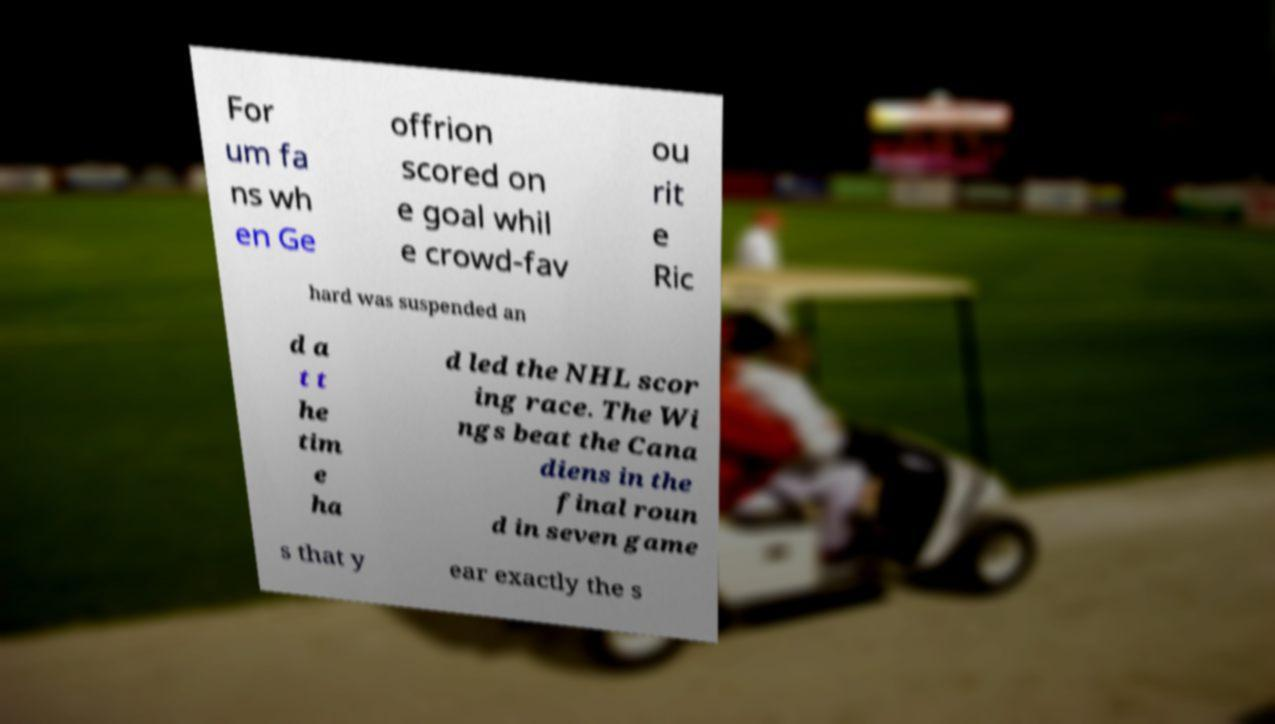I need the written content from this picture converted into text. Can you do that? For um fa ns wh en Ge offrion scored on e goal whil e crowd-fav ou rit e Ric hard was suspended an d a t t he tim e ha d led the NHL scor ing race. The Wi ngs beat the Cana diens in the final roun d in seven game s that y ear exactly the s 